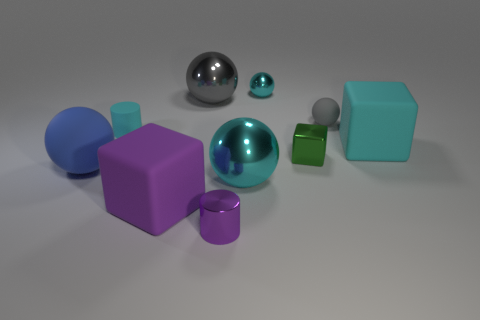Subtract all cyan spheres. How many spheres are left? 3 Subtract all big gray spheres. How many spheres are left? 4 Subtract 1 blocks. How many blocks are left? 2 Subtract all brown spheres. Subtract all gray cylinders. How many spheres are left? 5 Subtract all cylinders. How many objects are left? 8 Subtract 0 brown spheres. How many objects are left? 10 Subtract all cyan blocks. Subtract all gray objects. How many objects are left? 7 Add 3 blocks. How many blocks are left? 6 Add 8 purple matte blocks. How many purple matte blocks exist? 9 